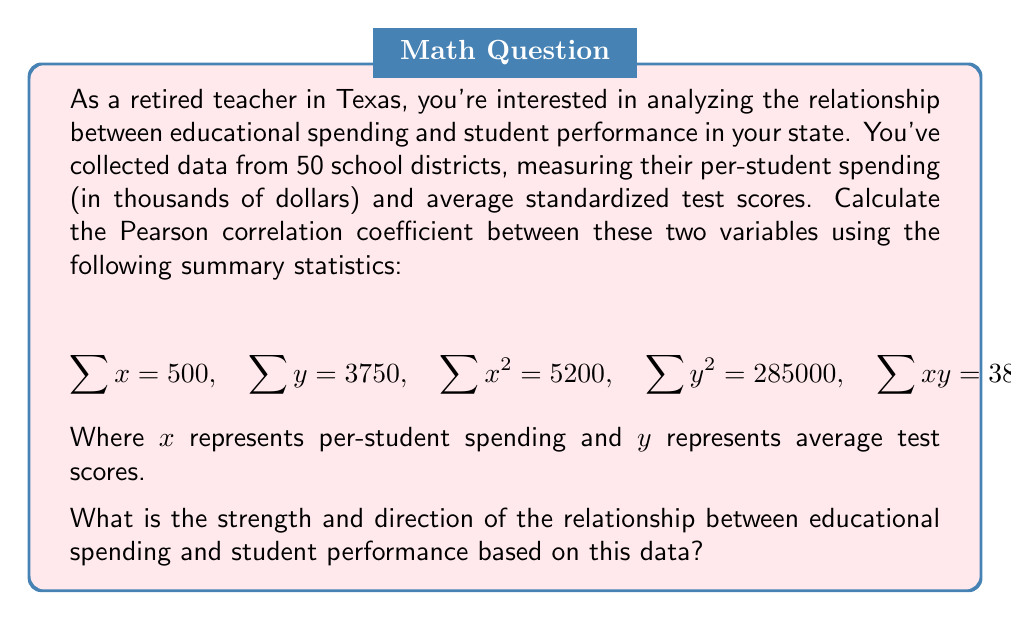Give your solution to this math problem. To calculate the Pearson correlation coefficient (r), we'll use the formula:

$$r = \frac{n\sum xy - \sum x \sum y}{\sqrt{[n\sum x^2 - (\sum x)^2][n\sum y^2 - (\sum y)^2]}}$$

Where n is the number of data points (50 in this case).

Step 1: Calculate $n\sum xy$
$n\sum xy = 50 \times 38000 = 1900000$

Step 2: Calculate $\sum x \sum y$
$\sum x \sum y = 500 \times 3750 = 1875000$

Step 3: Calculate the numerator
$1900000 - 1875000 = 25000$

Step 4: Calculate $n\sum x^2$ and $(\sum x)^2$
$n\sum x^2 = 50 \times 5200 = 260000$
$(\sum x)^2 = 500^2 = 250000$

Step 5: Calculate $n\sum y^2$ and $(\sum y)^2$
$n\sum y^2 = 50 \times 285000 = 14250000$
$(\sum y)^2 = 3750^2 = 14062500$

Step 6: Calculate the denominator
$\sqrt{[260000 - 250000][14250000 - 14062500]} = \sqrt{10000 \times 187500} = \sqrt{1875000000} = 43301.27$

Step 7: Calculate r
$r = \frac{25000}{43301.27} \approx 0.5773$

The Pearson correlation coefficient is approximately 0.5773, which indicates a moderate positive correlation between educational spending and student performance.
Answer: Moderate positive correlation (r ≈ 0.5773) 